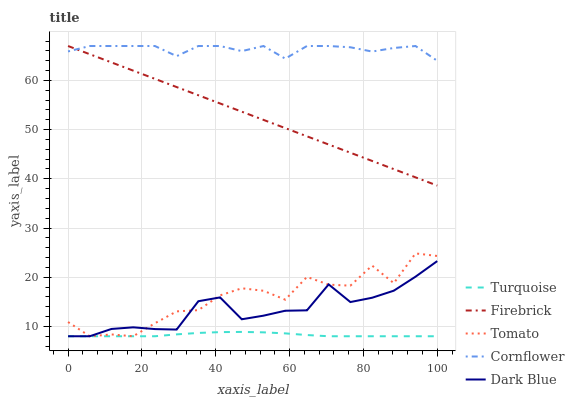Does Cornflower have the minimum area under the curve?
Answer yes or no. No. Does Turquoise have the maximum area under the curve?
Answer yes or no. No. Is Cornflower the smoothest?
Answer yes or no. No. Is Cornflower the roughest?
Answer yes or no. No. Does Cornflower have the lowest value?
Answer yes or no. No. Does Turquoise have the highest value?
Answer yes or no. No. Is Turquoise less than Cornflower?
Answer yes or no. Yes. Is Firebrick greater than Turquoise?
Answer yes or no. Yes. Does Turquoise intersect Cornflower?
Answer yes or no. No. 